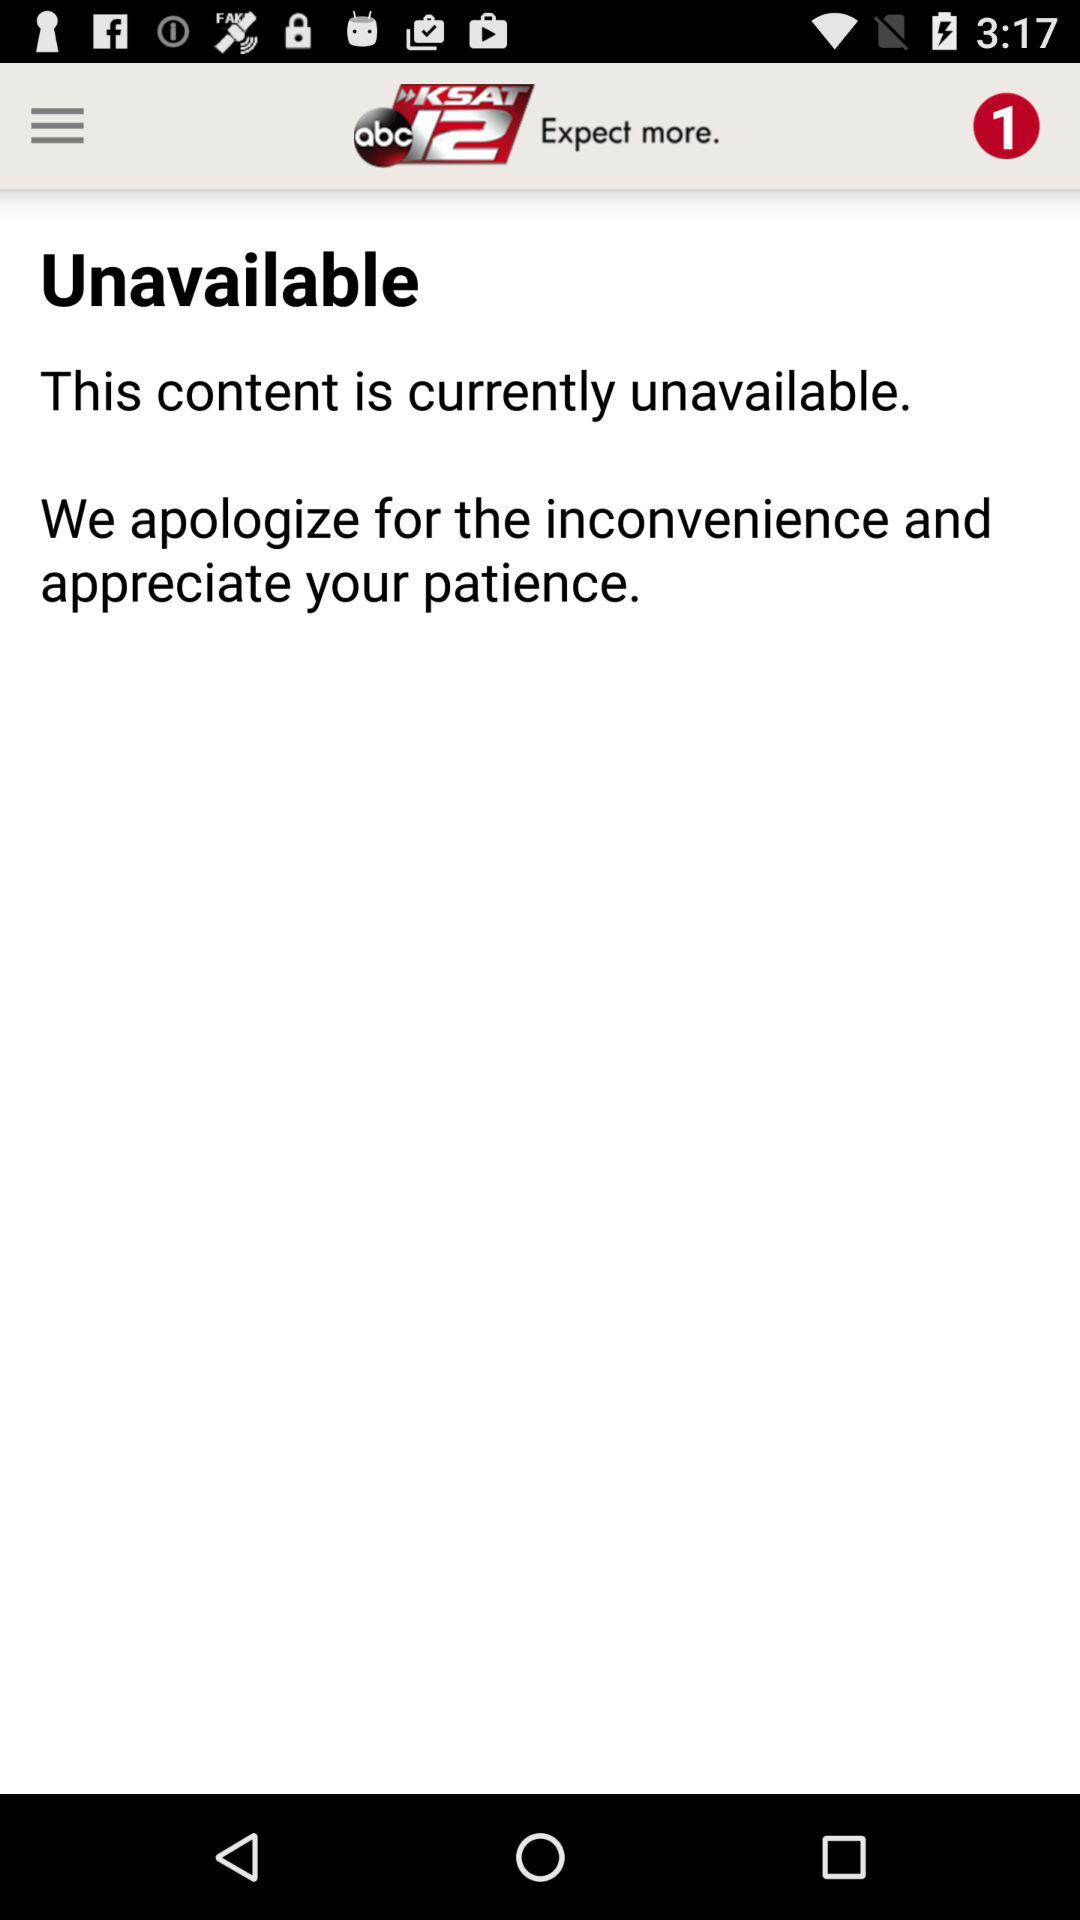What is the app name? The app name is "KSAT 12 News". 